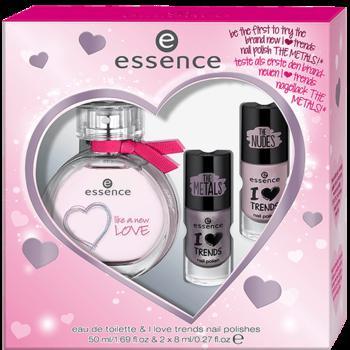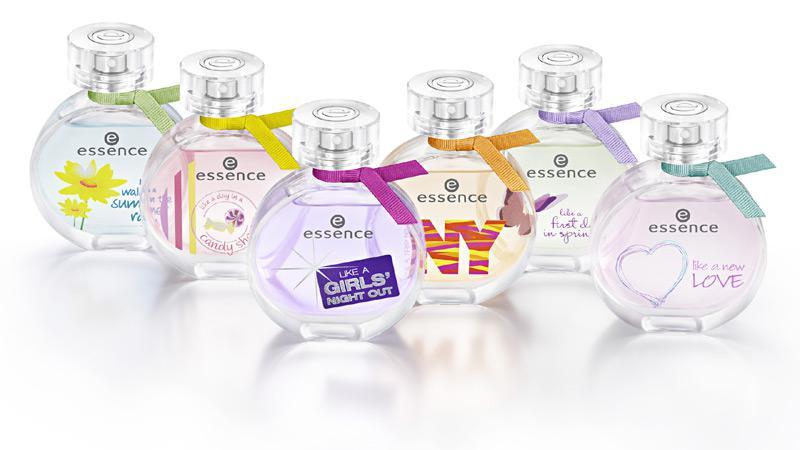The first image is the image on the left, the second image is the image on the right. Considering the images on both sides, is "there is only one cologne on the right image" valid? Answer yes or no. No. 